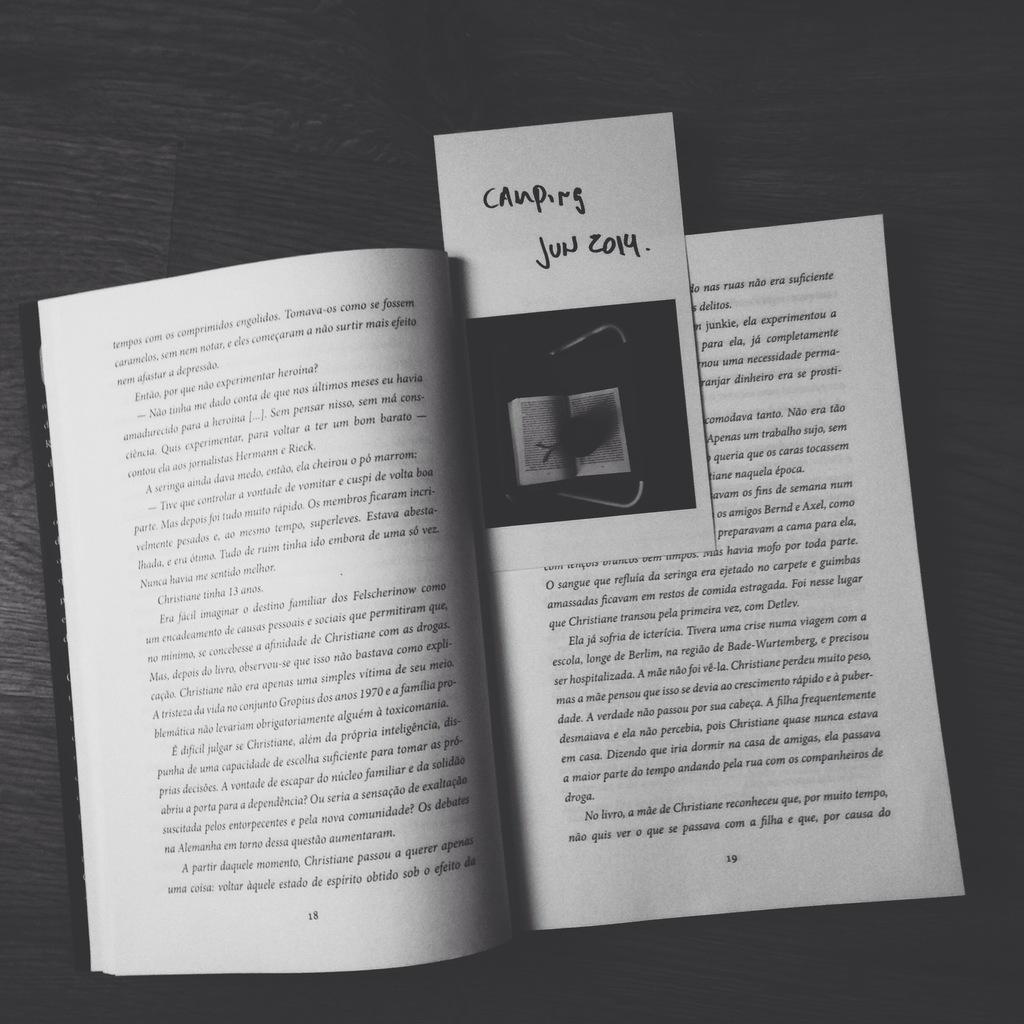What is the date shown?
Ensure brevity in your answer.  Jun 2014. In which page the book is open?
Provide a short and direct response. 19. 